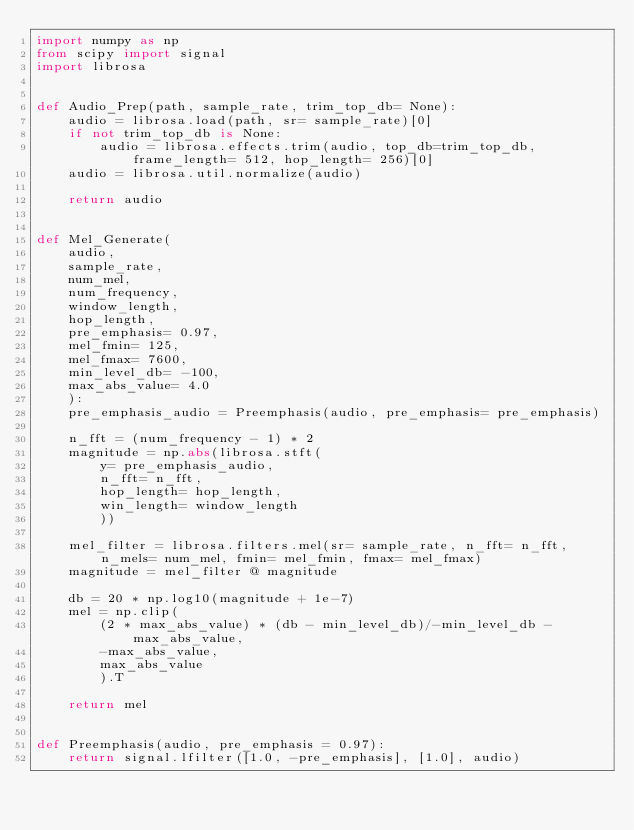<code> <loc_0><loc_0><loc_500><loc_500><_Python_>import numpy as np
from scipy import signal
import librosa


def Audio_Prep(path, sample_rate, trim_top_db= None):
    audio = librosa.load(path, sr= sample_rate)[0]
    if not trim_top_db is None:
        audio = librosa.effects.trim(audio, top_db=trim_top_db, frame_length= 512, hop_length= 256)[0]
    audio = librosa.util.normalize(audio)

    return audio


def Mel_Generate(
    audio,
    sample_rate,
    num_mel,
    num_frequency,
    window_length,
    hop_length,
    pre_emphasis= 0.97,
    mel_fmin= 125,
    mel_fmax= 7600,
    min_level_db= -100,
    max_abs_value= 4.0
    ):
    pre_emphasis_audio = Preemphasis(audio, pre_emphasis= pre_emphasis)
    
    n_fft = (num_frequency - 1) * 2
    magnitude = np.abs(librosa.stft(
        y= pre_emphasis_audio,
        n_fft= n_fft,
        hop_length= hop_length,
        win_length= window_length
        ))

    mel_filter = librosa.filters.mel(sr= sample_rate, n_fft= n_fft, n_mels= num_mel, fmin= mel_fmin, fmax= mel_fmax)
    magnitude = mel_filter @ magnitude
    
    db = 20 * np.log10(magnitude + 1e-7)
    mel = np.clip(
        (2 * max_abs_value) * (db - min_level_db)/-min_level_db - max_abs_value,
        -max_abs_value,
        max_abs_value
        ).T
    
    return mel 


def Preemphasis(audio, pre_emphasis = 0.97):
    return signal.lfilter([1.0, -pre_emphasis], [1.0], audio)

</code> 